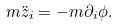<formula> <loc_0><loc_0><loc_500><loc_500>m \ddot { z } _ { i } = - m \partial _ { i } \phi .</formula> 